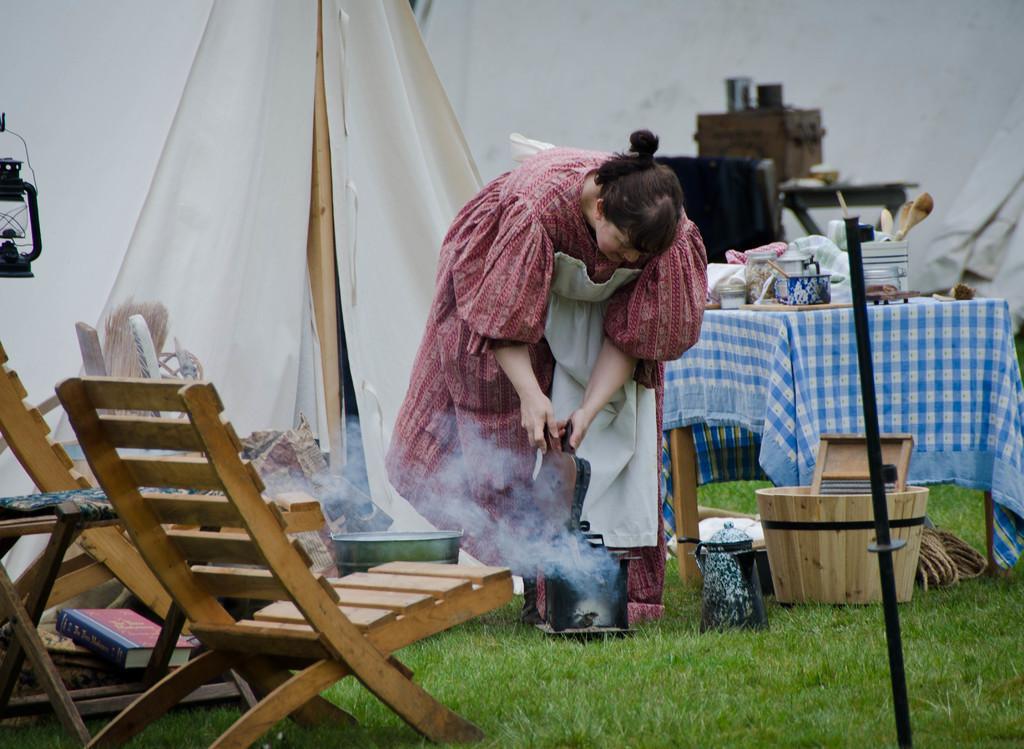Can you describe this image briefly? In this image there is a person standing. There are chairs and we can see a book. On the right there is a table and we can see things placed on the table. There is a container and we can see some objects placed on the grass. There is smoke. In the background there is a tent. On the left there is a lantern and we can see ropes. 